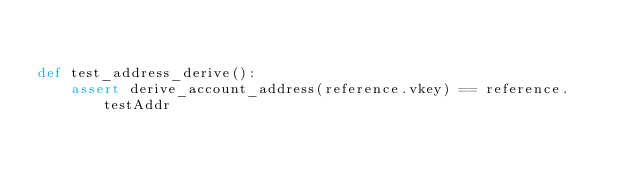Convert code to text. <code><loc_0><loc_0><loc_500><loc_500><_Python_>

def test_address_derive():
    assert derive_account_address(reference.vkey) == reference.testAddr
</code> 